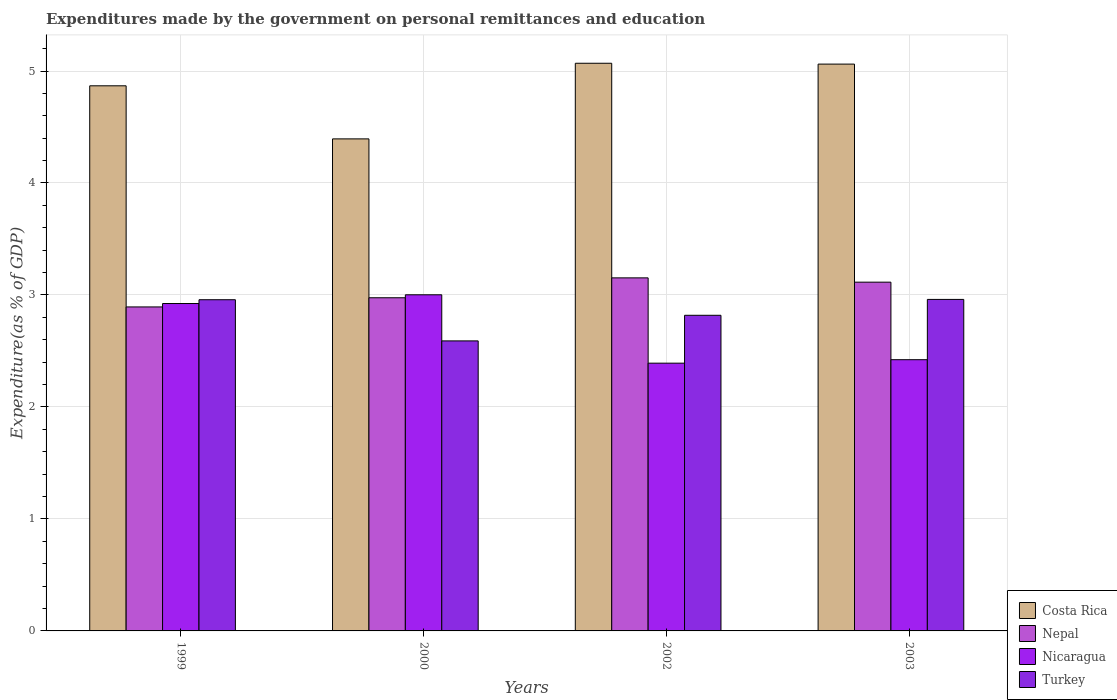How many different coloured bars are there?
Make the answer very short. 4. How many groups of bars are there?
Offer a very short reply. 4. Are the number of bars per tick equal to the number of legend labels?
Offer a very short reply. Yes. Are the number of bars on each tick of the X-axis equal?
Ensure brevity in your answer.  Yes. How many bars are there on the 3rd tick from the left?
Your response must be concise. 4. How many bars are there on the 2nd tick from the right?
Keep it short and to the point. 4. What is the label of the 4th group of bars from the left?
Make the answer very short. 2003. In how many cases, is the number of bars for a given year not equal to the number of legend labels?
Your response must be concise. 0. What is the expenditures made by the government on personal remittances and education in Nicaragua in 2003?
Give a very brief answer. 2.42. Across all years, what is the maximum expenditures made by the government on personal remittances and education in Nepal?
Provide a succinct answer. 3.15. Across all years, what is the minimum expenditures made by the government on personal remittances and education in Nepal?
Your answer should be very brief. 2.89. In which year was the expenditures made by the government on personal remittances and education in Turkey minimum?
Offer a very short reply. 2000. What is the total expenditures made by the government on personal remittances and education in Nepal in the graph?
Offer a terse response. 12.14. What is the difference between the expenditures made by the government on personal remittances and education in Turkey in 1999 and that in 2002?
Make the answer very short. 0.14. What is the difference between the expenditures made by the government on personal remittances and education in Turkey in 2003 and the expenditures made by the government on personal remittances and education in Nicaragua in 2002?
Your answer should be compact. 0.57. What is the average expenditures made by the government on personal remittances and education in Nepal per year?
Offer a terse response. 3.03. In the year 2000, what is the difference between the expenditures made by the government on personal remittances and education in Nepal and expenditures made by the government on personal remittances and education in Costa Rica?
Keep it short and to the point. -1.42. What is the ratio of the expenditures made by the government on personal remittances and education in Costa Rica in 2002 to that in 2003?
Make the answer very short. 1. Is the expenditures made by the government on personal remittances and education in Nepal in 1999 less than that in 2002?
Your answer should be very brief. Yes. Is the difference between the expenditures made by the government on personal remittances and education in Nepal in 2002 and 2003 greater than the difference between the expenditures made by the government on personal remittances and education in Costa Rica in 2002 and 2003?
Ensure brevity in your answer.  Yes. What is the difference between the highest and the second highest expenditures made by the government on personal remittances and education in Turkey?
Provide a succinct answer. 0. What is the difference between the highest and the lowest expenditures made by the government on personal remittances and education in Nepal?
Make the answer very short. 0.26. In how many years, is the expenditures made by the government on personal remittances and education in Turkey greater than the average expenditures made by the government on personal remittances and education in Turkey taken over all years?
Offer a very short reply. 2. What does the 2nd bar from the right in 2000 represents?
Keep it short and to the point. Nicaragua. Is it the case that in every year, the sum of the expenditures made by the government on personal remittances and education in Costa Rica and expenditures made by the government on personal remittances and education in Nepal is greater than the expenditures made by the government on personal remittances and education in Nicaragua?
Your answer should be compact. Yes. Are all the bars in the graph horizontal?
Offer a very short reply. No. How many years are there in the graph?
Keep it short and to the point. 4. What is the difference between two consecutive major ticks on the Y-axis?
Your answer should be very brief. 1. Where does the legend appear in the graph?
Offer a terse response. Bottom right. How many legend labels are there?
Keep it short and to the point. 4. How are the legend labels stacked?
Your answer should be very brief. Vertical. What is the title of the graph?
Your answer should be compact. Expenditures made by the government on personal remittances and education. What is the label or title of the Y-axis?
Your answer should be very brief. Expenditure(as % of GDP). What is the Expenditure(as % of GDP) of Costa Rica in 1999?
Offer a very short reply. 4.87. What is the Expenditure(as % of GDP) in Nepal in 1999?
Your answer should be compact. 2.89. What is the Expenditure(as % of GDP) of Nicaragua in 1999?
Give a very brief answer. 2.92. What is the Expenditure(as % of GDP) of Turkey in 1999?
Your answer should be very brief. 2.96. What is the Expenditure(as % of GDP) in Costa Rica in 2000?
Keep it short and to the point. 4.39. What is the Expenditure(as % of GDP) of Nepal in 2000?
Your response must be concise. 2.98. What is the Expenditure(as % of GDP) in Nicaragua in 2000?
Provide a succinct answer. 3. What is the Expenditure(as % of GDP) in Turkey in 2000?
Give a very brief answer. 2.59. What is the Expenditure(as % of GDP) of Costa Rica in 2002?
Your response must be concise. 5.07. What is the Expenditure(as % of GDP) of Nepal in 2002?
Your answer should be very brief. 3.15. What is the Expenditure(as % of GDP) of Nicaragua in 2002?
Your answer should be compact. 2.39. What is the Expenditure(as % of GDP) of Turkey in 2002?
Offer a terse response. 2.82. What is the Expenditure(as % of GDP) in Costa Rica in 2003?
Give a very brief answer. 5.06. What is the Expenditure(as % of GDP) of Nepal in 2003?
Your answer should be very brief. 3.11. What is the Expenditure(as % of GDP) of Nicaragua in 2003?
Offer a very short reply. 2.42. What is the Expenditure(as % of GDP) in Turkey in 2003?
Make the answer very short. 2.96. Across all years, what is the maximum Expenditure(as % of GDP) of Costa Rica?
Provide a succinct answer. 5.07. Across all years, what is the maximum Expenditure(as % of GDP) of Nepal?
Provide a short and direct response. 3.15. Across all years, what is the maximum Expenditure(as % of GDP) in Nicaragua?
Make the answer very short. 3. Across all years, what is the maximum Expenditure(as % of GDP) in Turkey?
Your response must be concise. 2.96. Across all years, what is the minimum Expenditure(as % of GDP) of Costa Rica?
Provide a succinct answer. 4.39. Across all years, what is the minimum Expenditure(as % of GDP) in Nepal?
Make the answer very short. 2.89. Across all years, what is the minimum Expenditure(as % of GDP) of Nicaragua?
Provide a short and direct response. 2.39. Across all years, what is the minimum Expenditure(as % of GDP) in Turkey?
Your answer should be very brief. 2.59. What is the total Expenditure(as % of GDP) in Costa Rica in the graph?
Keep it short and to the point. 19.39. What is the total Expenditure(as % of GDP) of Nepal in the graph?
Keep it short and to the point. 12.14. What is the total Expenditure(as % of GDP) of Nicaragua in the graph?
Make the answer very short. 10.74. What is the total Expenditure(as % of GDP) of Turkey in the graph?
Keep it short and to the point. 11.33. What is the difference between the Expenditure(as % of GDP) in Costa Rica in 1999 and that in 2000?
Provide a short and direct response. 0.47. What is the difference between the Expenditure(as % of GDP) in Nepal in 1999 and that in 2000?
Offer a terse response. -0.08. What is the difference between the Expenditure(as % of GDP) of Nicaragua in 1999 and that in 2000?
Ensure brevity in your answer.  -0.08. What is the difference between the Expenditure(as % of GDP) in Turkey in 1999 and that in 2000?
Your answer should be very brief. 0.37. What is the difference between the Expenditure(as % of GDP) of Costa Rica in 1999 and that in 2002?
Your answer should be compact. -0.2. What is the difference between the Expenditure(as % of GDP) in Nepal in 1999 and that in 2002?
Ensure brevity in your answer.  -0.26. What is the difference between the Expenditure(as % of GDP) of Nicaragua in 1999 and that in 2002?
Ensure brevity in your answer.  0.53. What is the difference between the Expenditure(as % of GDP) of Turkey in 1999 and that in 2002?
Your answer should be compact. 0.14. What is the difference between the Expenditure(as % of GDP) in Costa Rica in 1999 and that in 2003?
Your answer should be very brief. -0.19. What is the difference between the Expenditure(as % of GDP) of Nepal in 1999 and that in 2003?
Your answer should be compact. -0.22. What is the difference between the Expenditure(as % of GDP) in Nicaragua in 1999 and that in 2003?
Your answer should be very brief. 0.5. What is the difference between the Expenditure(as % of GDP) in Turkey in 1999 and that in 2003?
Provide a short and direct response. -0. What is the difference between the Expenditure(as % of GDP) in Costa Rica in 2000 and that in 2002?
Give a very brief answer. -0.68. What is the difference between the Expenditure(as % of GDP) of Nepal in 2000 and that in 2002?
Your response must be concise. -0.18. What is the difference between the Expenditure(as % of GDP) of Nicaragua in 2000 and that in 2002?
Make the answer very short. 0.61. What is the difference between the Expenditure(as % of GDP) of Turkey in 2000 and that in 2002?
Offer a very short reply. -0.23. What is the difference between the Expenditure(as % of GDP) of Costa Rica in 2000 and that in 2003?
Keep it short and to the point. -0.67. What is the difference between the Expenditure(as % of GDP) in Nepal in 2000 and that in 2003?
Ensure brevity in your answer.  -0.14. What is the difference between the Expenditure(as % of GDP) in Nicaragua in 2000 and that in 2003?
Make the answer very short. 0.58. What is the difference between the Expenditure(as % of GDP) of Turkey in 2000 and that in 2003?
Your answer should be very brief. -0.37. What is the difference between the Expenditure(as % of GDP) in Costa Rica in 2002 and that in 2003?
Provide a succinct answer. 0.01. What is the difference between the Expenditure(as % of GDP) in Nepal in 2002 and that in 2003?
Give a very brief answer. 0.04. What is the difference between the Expenditure(as % of GDP) of Nicaragua in 2002 and that in 2003?
Offer a very short reply. -0.03. What is the difference between the Expenditure(as % of GDP) of Turkey in 2002 and that in 2003?
Provide a short and direct response. -0.14. What is the difference between the Expenditure(as % of GDP) in Costa Rica in 1999 and the Expenditure(as % of GDP) in Nepal in 2000?
Provide a succinct answer. 1.89. What is the difference between the Expenditure(as % of GDP) in Costa Rica in 1999 and the Expenditure(as % of GDP) in Nicaragua in 2000?
Keep it short and to the point. 1.87. What is the difference between the Expenditure(as % of GDP) of Costa Rica in 1999 and the Expenditure(as % of GDP) of Turkey in 2000?
Provide a short and direct response. 2.28. What is the difference between the Expenditure(as % of GDP) of Nepal in 1999 and the Expenditure(as % of GDP) of Nicaragua in 2000?
Make the answer very short. -0.11. What is the difference between the Expenditure(as % of GDP) of Nepal in 1999 and the Expenditure(as % of GDP) of Turkey in 2000?
Your answer should be compact. 0.3. What is the difference between the Expenditure(as % of GDP) in Nicaragua in 1999 and the Expenditure(as % of GDP) in Turkey in 2000?
Keep it short and to the point. 0.33. What is the difference between the Expenditure(as % of GDP) in Costa Rica in 1999 and the Expenditure(as % of GDP) in Nepal in 2002?
Offer a very short reply. 1.72. What is the difference between the Expenditure(as % of GDP) of Costa Rica in 1999 and the Expenditure(as % of GDP) of Nicaragua in 2002?
Provide a succinct answer. 2.48. What is the difference between the Expenditure(as % of GDP) of Costa Rica in 1999 and the Expenditure(as % of GDP) of Turkey in 2002?
Your answer should be compact. 2.05. What is the difference between the Expenditure(as % of GDP) in Nepal in 1999 and the Expenditure(as % of GDP) in Nicaragua in 2002?
Offer a very short reply. 0.5. What is the difference between the Expenditure(as % of GDP) in Nepal in 1999 and the Expenditure(as % of GDP) in Turkey in 2002?
Provide a short and direct response. 0.07. What is the difference between the Expenditure(as % of GDP) of Nicaragua in 1999 and the Expenditure(as % of GDP) of Turkey in 2002?
Your response must be concise. 0.1. What is the difference between the Expenditure(as % of GDP) in Costa Rica in 1999 and the Expenditure(as % of GDP) in Nepal in 2003?
Give a very brief answer. 1.75. What is the difference between the Expenditure(as % of GDP) in Costa Rica in 1999 and the Expenditure(as % of GDP) in Nicaragua in 2003?
Offer a terse response. 2.45. What is the difference between the Expenditure(as % of GDP) in Costa Rica in 1999 and the Expenditure(as % of GDP) in Turkey in 2003?
Ensure brevity in your answer.  1.91. What is the difference between the Expenditure(as % of GDP) of Nepal in 1999 and the Expenditure(as % of GDP) of Nicaragua in 2003?
Provide a short and direct response. 0.47. What is the difference between the Expenditure(as % of GDP) in Nepal in 1999 and the Expenditure(as % of GDP) in Turkey in 2003?
Keep it short and to the point. -0.07. What is the difference between the Expenditure(as % of GDP) of Nicaragua in 1999 and the Expenditure(as % of GDP) of Turkey in 2003?
Your answer should be very brief. -0.04. What is the difference between the Expenditure(as % of GDP) in Costa Rica in 2000 and the Expenditure(as % of GDP) in Nepal in 2002?
Provide a short and direct response. 1.24. What is the difference between the Expenditure(as % of GDP) of Costa Rica in 2000 and the Expenditure(as % of GDP) of Nicaragua in 2002?
Provide a succinct answer. 2. What is the difference between the Expenditure(as % of GDP) in Costa Rica in 2000 and the Expenditure(as % of GDP) in Turkey in 2002?
Offer a very short reply. 1.58. What is the difference between the Expenditure(as % of GDP) of Nepal in 2000 and the Expenditure(as % of GDP) of Nicaragua in 2002?
Keep it short and to the point. 0.58. What is the difference between the Expenditure(as % of GDP) of Nepal in 2000 and the Expenditure(as % of GDP) of Turkey in 2002?
Make the answer very short. 0.16. What is the difference between the Expenditure(as % of GDP) of Nicaragua in 2000 and the Expenditure(as % of GDP) of Turkey in 2002?
Provide a succinct answer. 0.18. What is the difference between the Expenditure(as % of GDP) of Costa Rica in 2000 and the Expenditure(as % of GDP) of Nepal in 2003?
Offer a very short reply. 1.28. What is the difference between the Expenditure(as % of GDP) in Costa Rica in 2000 and the Expenditure(as % of GDP) in Nicaragua in 2003?
Your answer should be compact. 1.97. What is the difference between the Expenditure(as % of GDP) in Costa Rica in 2000 and the Expenditure(as % of GDP) in Turkey in 2003?
Keep it short and to the point. 1.43. What is the difference between the Expenditure(as % of GDP) of Nepal in 2000 and the Expenditure(as % of GDP) of Nicaragua in 2003?
Keep it short and to the point. 0.55. What is the difference between the Expenditure(as % of GDP) of Nepal in 2000 and the Expenditure(as % of GDP) of Turkey in 2003?
Make the answer very short. 0.01. What is the difference between the Expenditure(as % of GDP) of Nicaragua in 2000 and the Expenditure(as % of GDP) of Turkey in 2003?
Make the answer very short. 0.04. What is the difference between the Expenditure(as % of GDP) of Costa Rica in 2002 and the Expenditure(as % of GDP) of Nepal in 2003?
Give a very brief answer. 1.95. What is the difference between the Expenditure(as % of GDP) in Costa Rica in 2002 and the Expenditure(as % of GDP) in Nicaragua in 2003?
Give a very brief answer. 2.65. What is the difference between the Expenditure(as % of GDP) in Costa Rica in 2002 and the Expenditure(as % of GDP) in Turkey in 2003?
Make the answer very short. 2.11. What is the difference between the Expenditure(as % of GDP) of Nepal in 2002 and the Expenditure(as % of GDP) of Nicaragua in 2003?
Offer a terse response. 0.73. What is the difference between the Expenditure(as % of GDP) of Nepal in 2002 and the Expenditure(as % of GDP) of Turkey in 2003?
Offer a very short reply. 0.19. What is the difference between the Expenditure(as % of GDP) of Nicaragua in 2002 and the Expenditure(as % of GDP) of Turkey in 2003?
Offer a very short reply. -0.57. What is the average Expenditure(as % of GDP) in Costa Rica per year?
Ensure brevity in your answer.  4.85. What is the average Expenditure(as % of GDP) in Nepal per year?
Provide a short and direct response. 3.03. What is the average Expenditure(as % of GDP) of Nicaragua per year?
Make the answer very short. 2.68. What is the average Expenditure(as % of GDP) of Turkey per year?
Give a very brief answer. 2.83. In the year 1999, what is the difference between the Expenditure(as % of GDP) in Costa Rica and Expenditure(as % of GDP) in Nepal?
Give a very brief answer. 1.97. In the year 1999, what is the difference between the Expenditure(as % of GDP) of Costa Rica and Expenditure(as % of GDP) of Nicaragua?
Make the answer very short. 1.94. In the year 1999, what is the difference between the Expenditure(as % of GDP) of Costa Rica and Expenditure(as % of GDP) of Turkey?
Keep it short and to the point. 1.91. In the year 1999, what is the difference between the Expenditure(as % of GDP) in Nepal and Expenditure(as % of GDP) in Nicaragua?
Keep it short and to the point. -0.03. In the year 1999, what is the difference between the Expenditure(as % of GDP) of Nepal and Expenditure(as % of GDP) of Turkey?
Ensure brevity in your answer.  -0.06. In the year 1999, what is the difference between the Expenditure(as % of GDP) of Nicaragua and Expenditure(as % of GDP) of Turkey?
Keep it short and to the point. -0.03. In the year 2000, what is the difference between the Expenditure(as % of GDP) of Costa Rica and Expenditure(as % of GDP) of Nepal?
Provide a short and direct response. 1.42. In the year 2000, what is the difference between the Expenditure(as % of GDP) in Costa Rica and Expenditure(as % of GDP) in Nicaragua?
Provide a succinct answer. 1.39. In the year 2000, what is the difference between the Expenditure(as % of GDP) of Costa Rica and Expenditure(as % of GDP) of Turkey?
Offer a terse response. 1.8. In the year 2000, what is the difference between the Expenditure(as % of GDP) of Nepal and Expenditure(as % of GDP) of Nicaragua?
Your answer should be very brief. -0.03. In the year 2000, what is the difference between the Expenditure(as % of GDP) of Nepal and Expenditure(as % of GDP) of Turkey?
Provide a succinct answer. 0.39. In the year 2000, what is the difference between the Expenditure(as % of GDP) in Nicaragua and Expenditure(as % of GDP) in Turkey?
Give a very brief answer. 0.41. In the year 2002, what is the difference between the Expenditure(as % of GDP) of Costa Rica and Expenditure(as % of GDP) of Nepal?
Your response must be concise. 1.92. In the year 2002, what is the difference between the Expenditure(as % of GDP) in Costa Rica and Expenditure(as % of GDP) in Nicaragua?
Your response must be concise. 2.68. In the year 2002, what is the difference between the Expenditure(as % of GDP) of Costa Rica and Expenditure(as % of GDP) of Turkey?
Keep it short and to the point. 2.25. In the year 2002, what is the difference between the Expenditure(as % of GDP) in Nepal and Expenditure(as % of GDP) in Nicaragua?
Your answer should be compact. 0.76. In the year 2002, what is the difference between the Expenditure(as % of GDP) in Nepal and Expenditure(as % of GDP) in Turkey?
Your answer should be very brief. 0.33. In the year 2002, what is the difference between the Expenditure(as % of GDP) in Nicaragua and Expenditure(as % of GDP) in Turkey?
Provide a succinct answer. -0.43. In the year 2003, what is the difference between the Expenditure(as % of GDP) of Costa Rica and Expenditure(as % of GDP) of Nepal?
Give a very brief answer. 1.95. In the year 2003, what is the difference between the Expenditure(as % of GDP) of Costa Rica and Expenditure(as % of GDP) of Nicaragua?
Offer a terse response. 2.64. In the year 2003, what is the difference between the Expenditure(as % of GDP) in Costa Rica and Expenditure(as % of GDP) in Turkey?
Give a very brief answer. 2.1. In the year 2003, what is the difference between the Expenditure(as % of GDP) of Nepal and Expenditure(as % of GDP) of Nicaragua?
Provide a succinct answer. 0.69. In the year 2003, what is the difference between the Expenditure(as % of GDP) in Nepal and Expenditure(as % of GDP) in Turkey?
Give a very brief answer. 0.15. In the year 2003, what is the difference between the Expenditure(as % of GDP) in Nicaragua and Expenditure(as % of GDP) in Turkey?
Ensure brevity in your answer.  -0.54. What is the ratio of the Expenditure(as % of GDP) in Costa Rica in 1999 to that in 2000?
Your response must be concise. 1.11. What is the ratio of the Expenditure(as % of GDP) in Nepal in 1999 to that in 2000?
Your response must be concise. 0.97. What is the ratio of the Expenditure(as % of GDP) of Nicaragua in 1999 to that in 2000?
Offer a very short reply. 0.97. What is the ratio of the Expenditure(as % of GDP) in Turkey in 1999 to that in 2000?
Keep it short and to the point. 1.14. What is the ratio of the Expenditure(as % of GDP) in Costa Rica in 1999 to that in 2002?
Give a very brief answer. 0.96. What is the ratio of the Expenditure(as % of GDP) in Nepal in 1999 to that in 2002?
Offer a terse response. 0.92. What is the ratio of the Expenditure(as % of GDP) in Nicaragua in 1999 to that in 2002?
Keep it short and to the point. 1.22. What is the ratio of the Expenditure(as % of GDP) in Turkey in 1999 to that in 2002?
Make the answer very short. 1.05. What is the ratio of the Expenditure(as % of GDP) in Costa Rica in 1999 to that in 2003?
Offer a very short reply. 0.96. What is the ratio of the Expenditure(as % of GDP) in Nepal in 1999 to that in 2003?
Your answer should be very brief. 0.93. What is the ratio of the Expenditure(as % of GDP) in Nicaragua in 1999 to that in 2003?
Give a very brief answer. 1.21. What is the ratio of the Expenditure(as % of GDP) in Turkey in 1999 to that in 2003?
Give a very brief answer. 1. What is the ratio of the Expenditure(as % of GDP) of Costa Rica in 2000 to that in 2002?
Give a very brief answer. 0.87. What is the ratio of the Expenditure(as % of GDP) in Nepal in 2000 to that in 2002?
Ensure brevity in your answer.  0.94. What is the ratio of the Expenditure(as % of GDP) of Nicaragua in 2000 to that in 2002?
Make the answer very short. 1.26. What is the ratio of the Expenditure(as % of GDP) in Turkey in 2000 to that in 2002?
Make the answer very short. 0.92. What is the ratio of the Expenditure(as % of GDP) in Costa Rica in 2000 to that in 2003?
Provide a succinct answer. 0.87. What is the ratio of the Expenditure(as % of GDP) in Nepal in 2000 to that in 2003?
Provide a short and direct response. 0.96. What is the ratio of the Expenditure(as % of GDP) of Nicaragua in 2000 to that in 2003?
Keep it short and to the point. 1.24. What is the ratio of the Expenditure(as % of GDP) of Turkey in 2000 to that in 2003?
Give a very brief answer. 0.87. What is the ratio of the Expenditure(as % of GDP) in Costa Rica in 2002 to that in 2003?
Offer a terse response. 1. What is the ratio of the Expenditure(as % of GDP) of Nepal in 2002 to that in 2003?
Provide a succinct answer. 1.01. What is the ratio of the Expenditure(as % of GDP) in Nicaragua in 2002 to that in 2003?
Make the answer very short. 0.99. What is the ratio of the Expenditure(as % of GDP) of Turkey in 2002 to that in 2003?
Make the answer very short. 0.95. What is the difference between the highest and the second highest Expenditure(as % of GDP) of Costa Rica?
Offer a terse response. 0.01. What is the difference between the highest and the second highest Expenditure(as % of GDP) in Nepal?
Your response must be concise. 0.04. What is the difference between the highest and the second highest Expenditure(as % of GDP) of Nicaragua?
Ensure brevity in your answer.  0.08. What is the difference between the highest and the second highest Expenditure(as % of GDP) in Turkey?
Offer a very short reply. 0. What is the difference between the highest and the lowest Expenditure(as % of GDP) of Costa Rica?
Your answer should be compact. 0.68. What is the difference between the highest and the lowest Expenditure(as % of GDP) of Nepal?
Offer a very short reply. 0.26. What is the difference between the highest and the lowest Expenditure(as % of GDP) of Nicaragua?
Offer a terse response. 0.61. What is the difference between the highest and the lowest Expenditure(as % of GDP) in Turkey?
Provide a succinct answer. 0.37. 